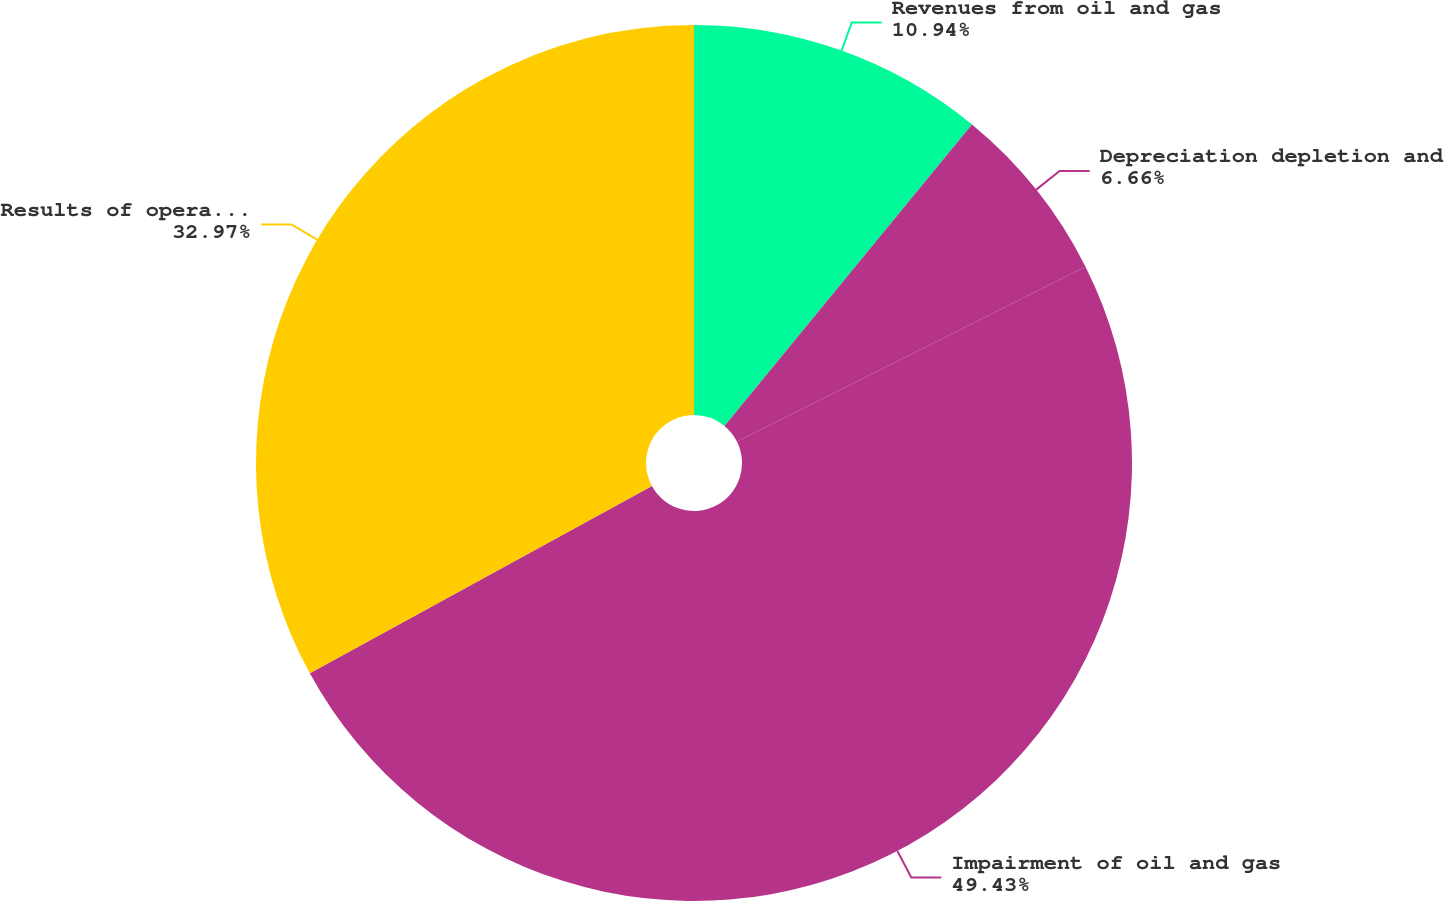Convert chart. <chart><loc_0><loc_0><loc_500><loc_500><pie_chart><fcel>Revenues from oil and gas<fcel>Depreciation depletion and<fcel>Impairment of oil and gas<fcel>Results of operations from oil<nl><fcel>10.94%<fcel>6.66%<fcel>49.42%<fcel>32.97%<nl></chart> 